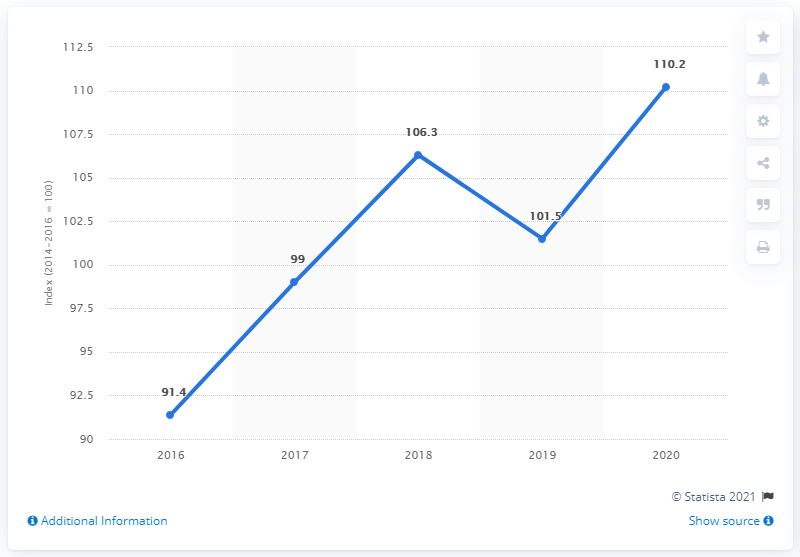List a handful of essential elements in this visual. The index for rice in 2020 was 110.2. According to the previous year's index, the average price of rice was 101.5. 